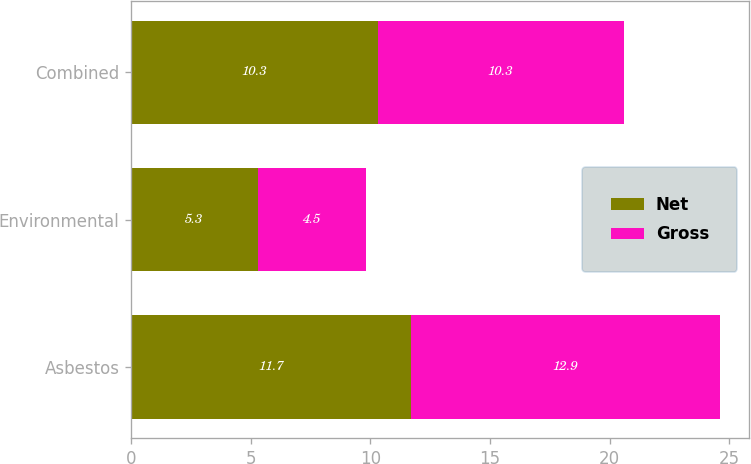Convert chart. <chart><loc_0><loc_0><loc_500><loc_500><stacked_bar_chart><ecel><fcel>Asbestos<fcel>Environmental<fcel>Combined<nl><fcel>Net<fcel>11.7<fcel>5.3<fcel>10.3<nl><fcel>Gross<fcel>12.9<fcel>4.5<fcel>10.3<nl></chart> 